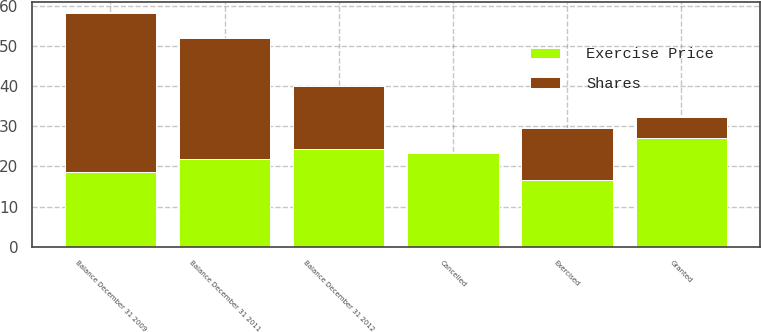<chart> <loc_0><loc_0><loc_500><loc_500><stacked_bar_chart><ecel><fcel>Balance December 31 2009<fcel>Granted<fcel>Exercised<fcel>Cancelled<fcel>Balance December 31 2011<fcel>Balance December 31 2012<nl><fcel>Shares<fcel>39.5<fcel>5.1<fcel>12.9<fcel>0.1<fcel>30.4<fcel>15.8<nl><fcel>Exercise Price<fcel>18.73<fcel>27.15<fcel>16.59<fcel>23.33<fcel>21.78<fcel>24.39<nl></chart> 